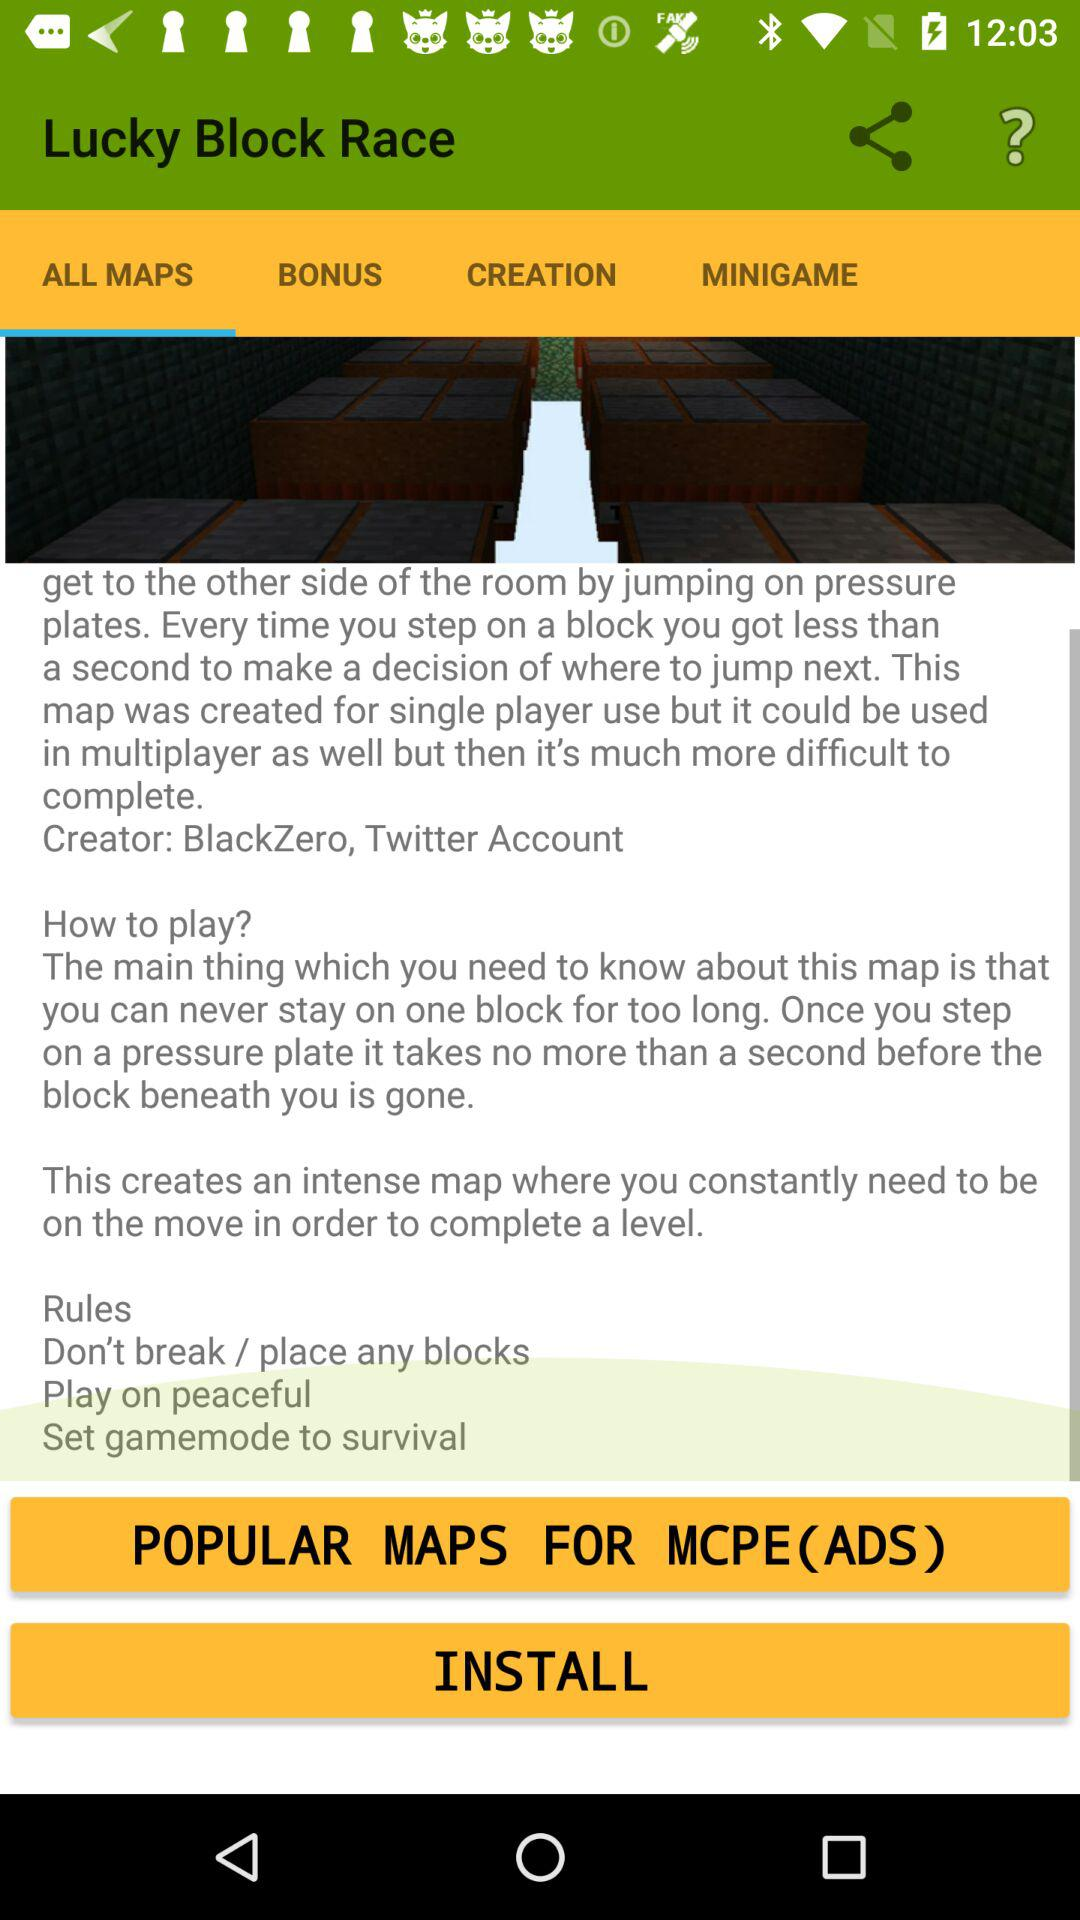What tab am I using? The tab is "ALL MAPS". 